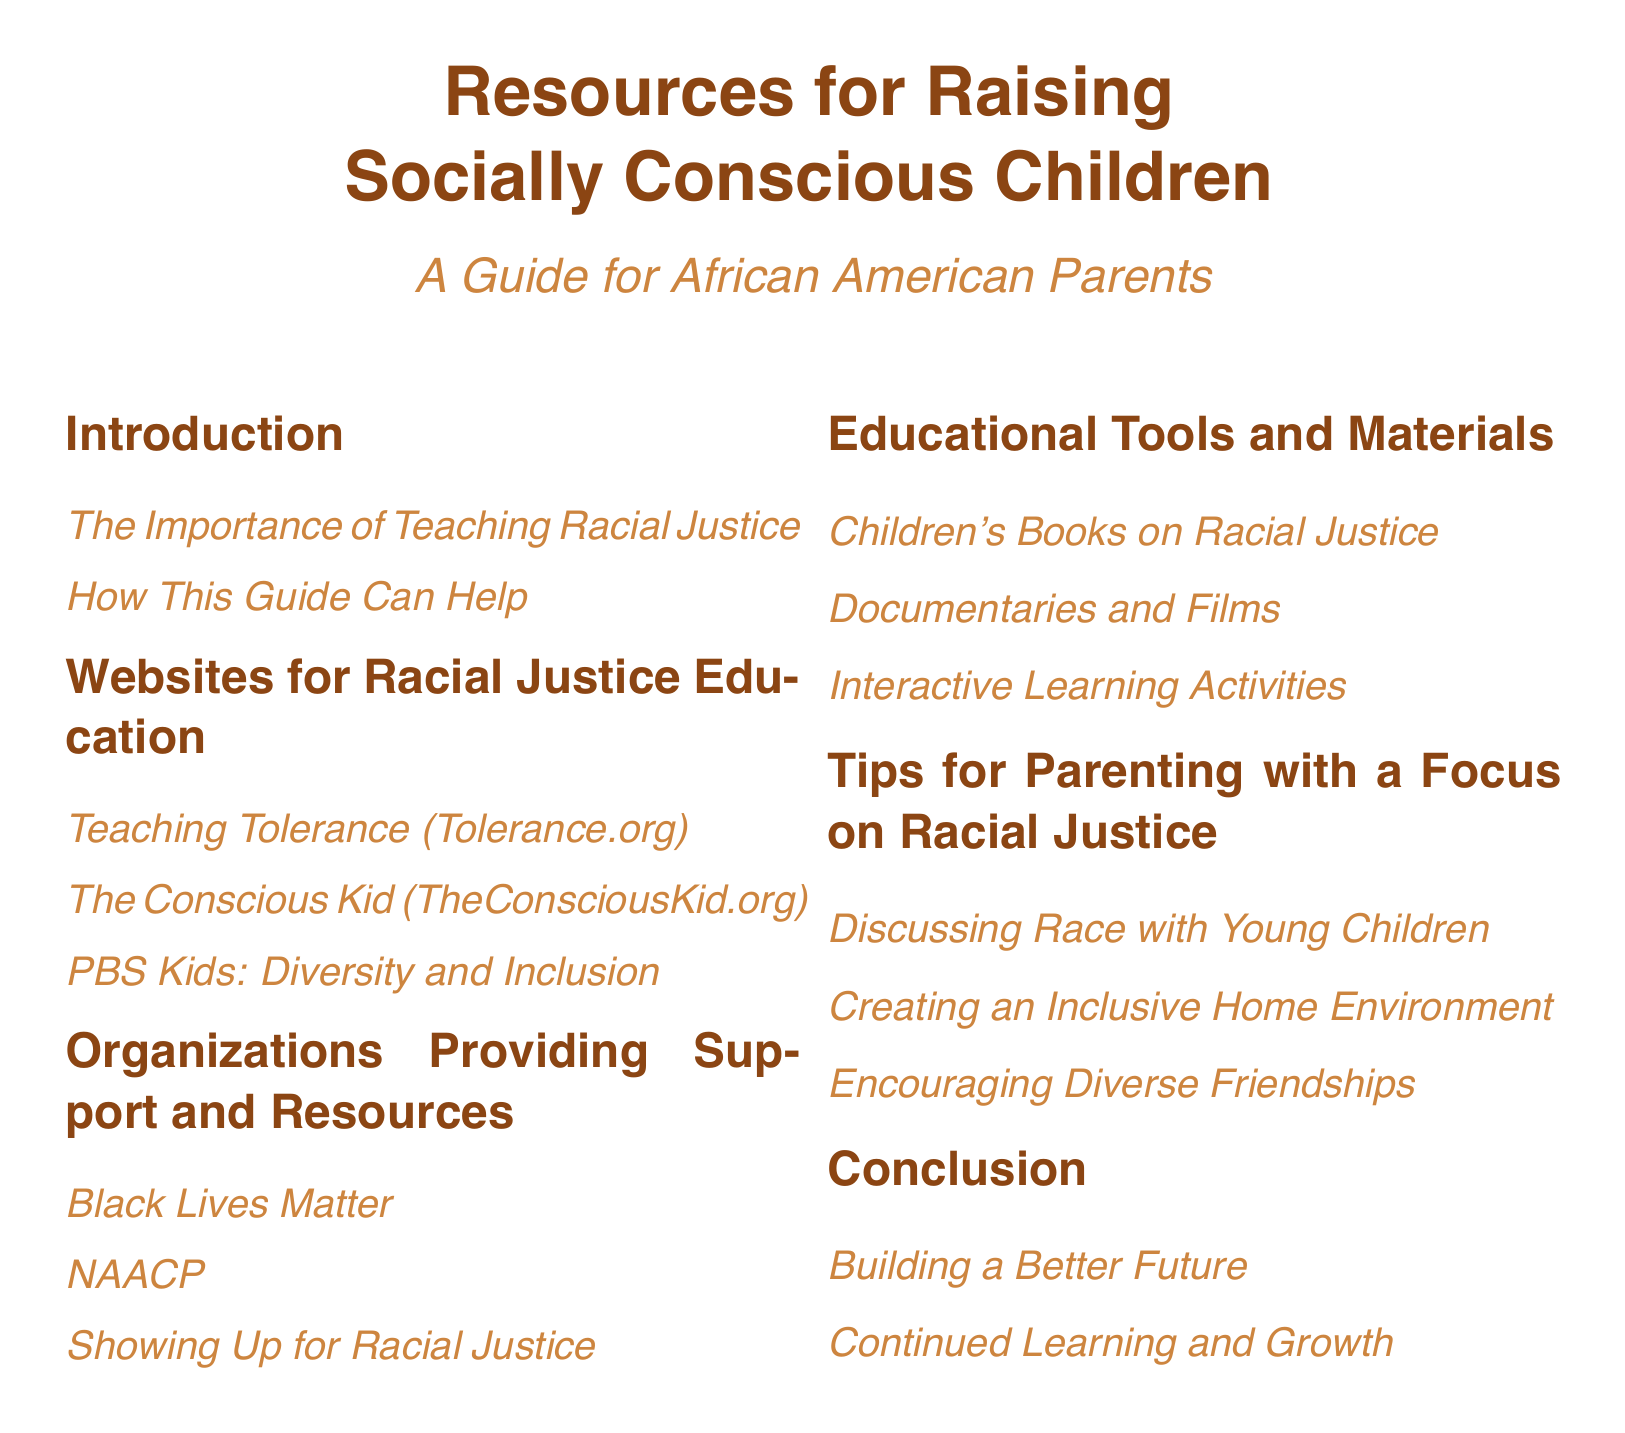What is the title of the guide? The title is clearly stated at the beginning of the document as part of the introduction.
Answer: Resources for Raising Socially Conscious Children How many sections are in the document? The sections can be counted in the table of contents, which lists them.
Answer: Six What organization is listed as providing support and resources? Organizations that appear in the document can be directly identified from the relevant section.
Answer: Black Lives Matter What type of resources are included under Educational Tools and Materials? This segment specifically outlines the types of materials provided in that section.
Answer: Children's Books on Racial Justice What is the focus of the Tips for Parenting section? The subheadings detail what the tips will address in this section.
Answer: Racial Justice What is the main purpose of the guide? The main aim of the guide is indicated in the introduction section.
Answer: Teaching Racial Justice Which website focuses on teaching tolerance? Specific websites are mentioned in the websites section for educational resources.
Answer: Teaching Tolerance (Tolerance.org) What is suggested for creating a welcoming atmosphere at home? This can be inferred from the second subheading under the tips section.
Answer: Creating an Inclusive Home Environment 